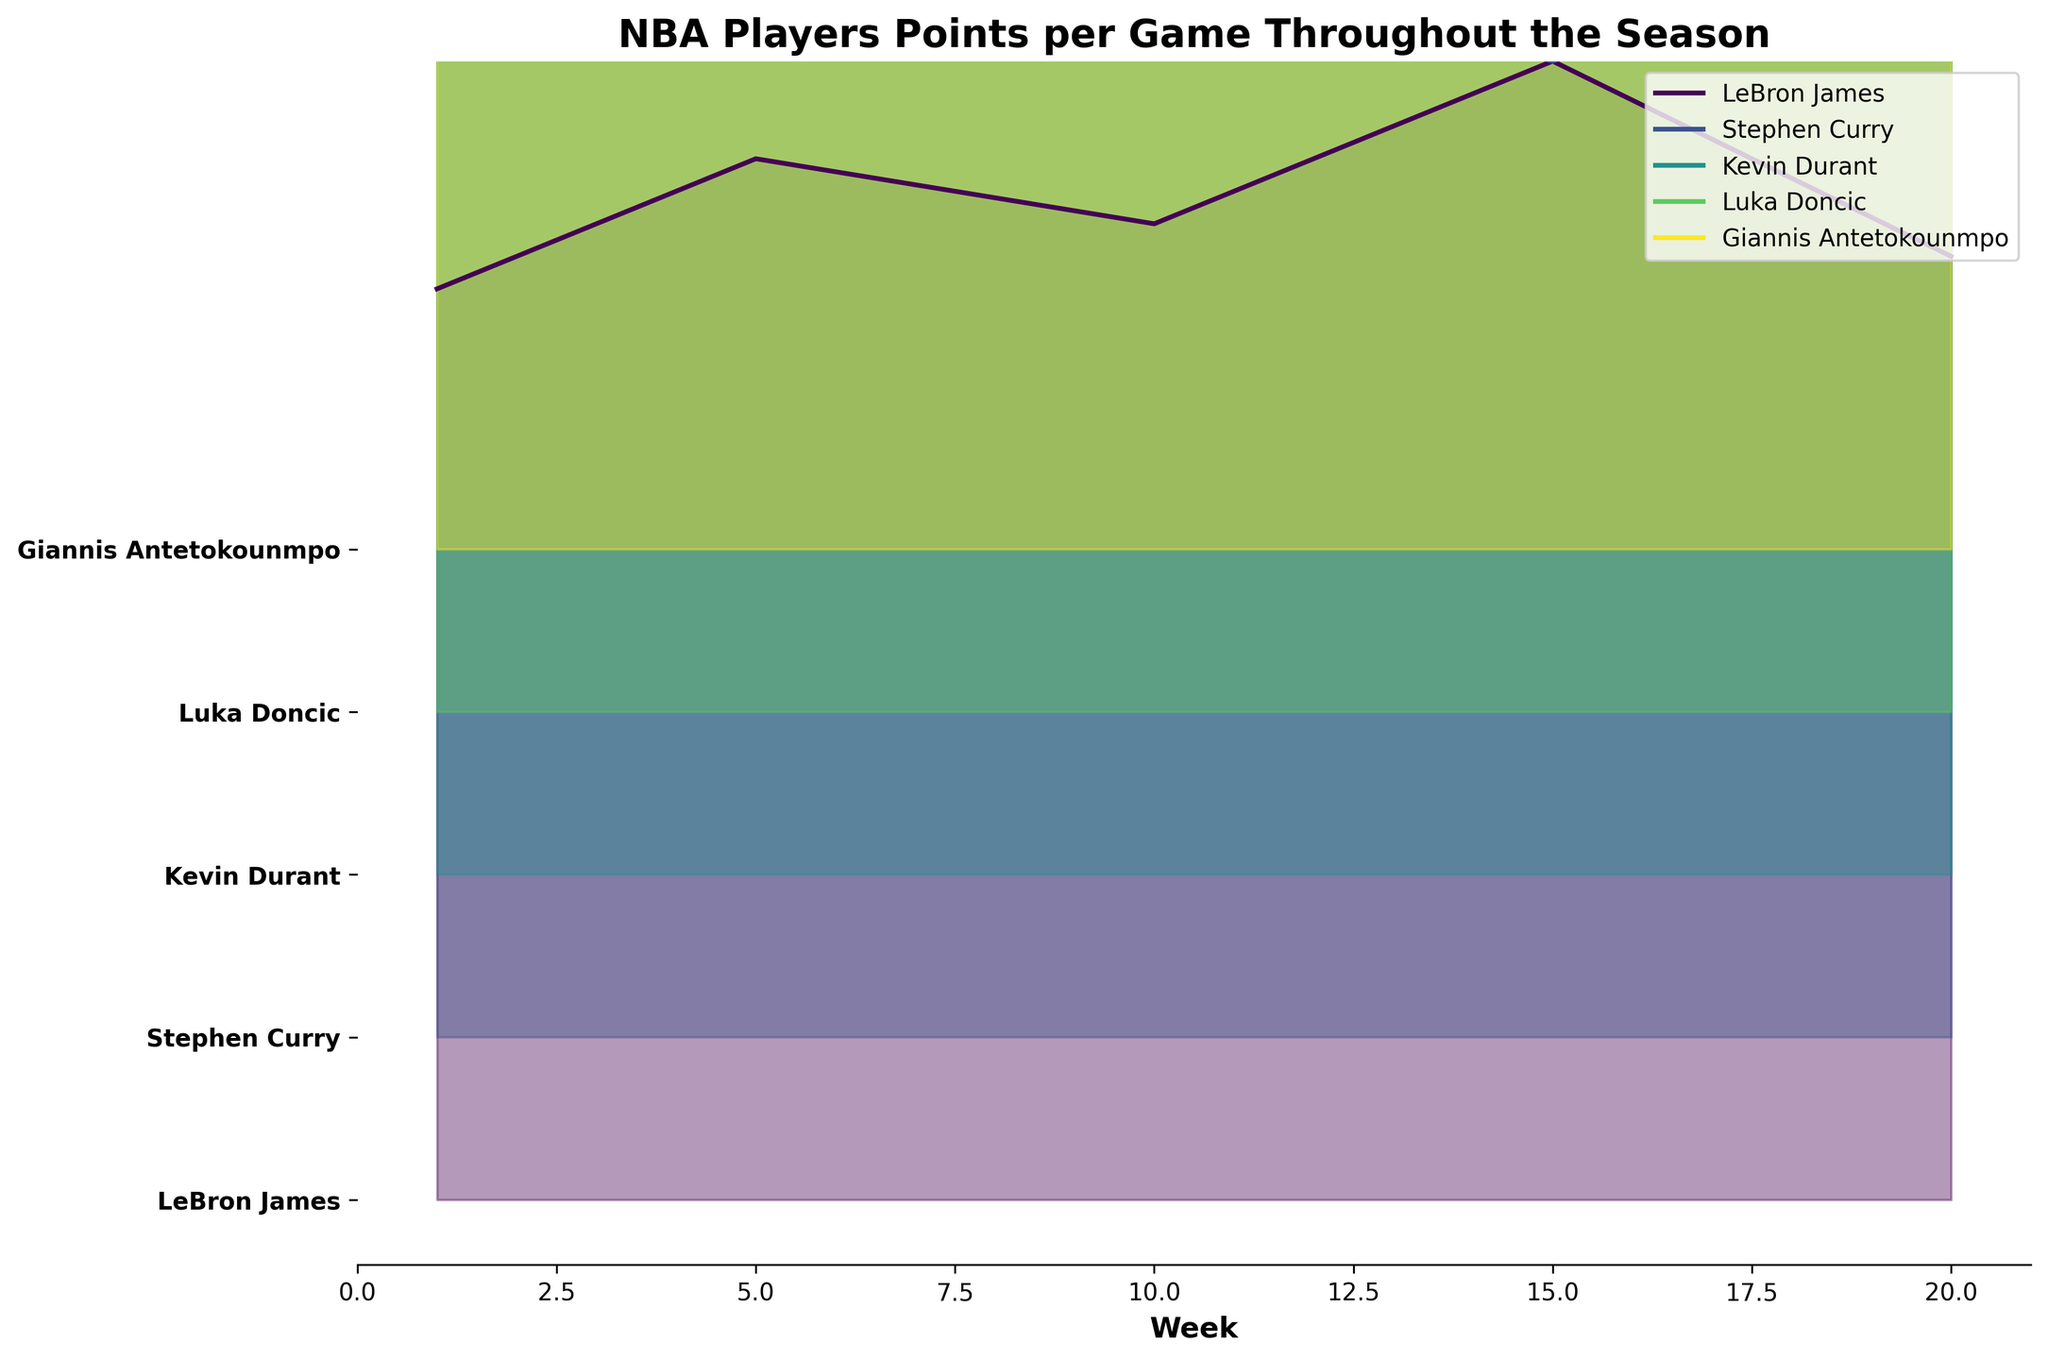What's the title of the plot? The title of the plot is written at the top of the figure.
Answer: NBA Players Points per Game Throughout the Season How many players are represented in the plot? The number of players can be found by counting the distinct labels along the y-axis.
Answer: 5 What is the color scheme used in the plot? The color scheme refers to the palette used for the different lines and fill areas on the plot.
Answer: Viridis Which player has the highest peak point value on the plot? Identify the player whose peak value is the highest among all the players' lines in the plot. Luka Doncic has the highest peak point value of 36 points during week 15.
Answer: Luka Doncic Did Stephen Curry score more points on Week 10 or Week 15? Compare Stephen Curry's points from Week 10 (33 points) and Week 15 (30 points).
Answer: Week 10 What is the range of weeks represented on the x-axis? The range of weeks can be identified by checking the labels on the x-axis, which spans from Week 0 to Week 20.
Answer: 1 to 20 Which player shows the most consistent scoring trend across all weeks? Consistency can be assessed by looking at how much the points change from week to week for each player. LeBron James’ scores appear to fluctuate less compared to the others.
Answer: LeBron James What's the average number of points scored in Week 10 across all players? Sum the points scored by all players in Week 10 (LeBron James 30, Stephen Curry 33, Kevin Durant 34, Luka Doncic 31, Giannis Antetokounmpo 32) and divide by the number of players (5).
Answer: 32 Between LeBron James and Kevin Durant, who had more fluctuations in scoring throughout the season? Fluctuations are determined by how much the points per game change from week to week. Kevin Durant’s point range is more diverse compared to LeBron James.
Answer: Kevin Durant 